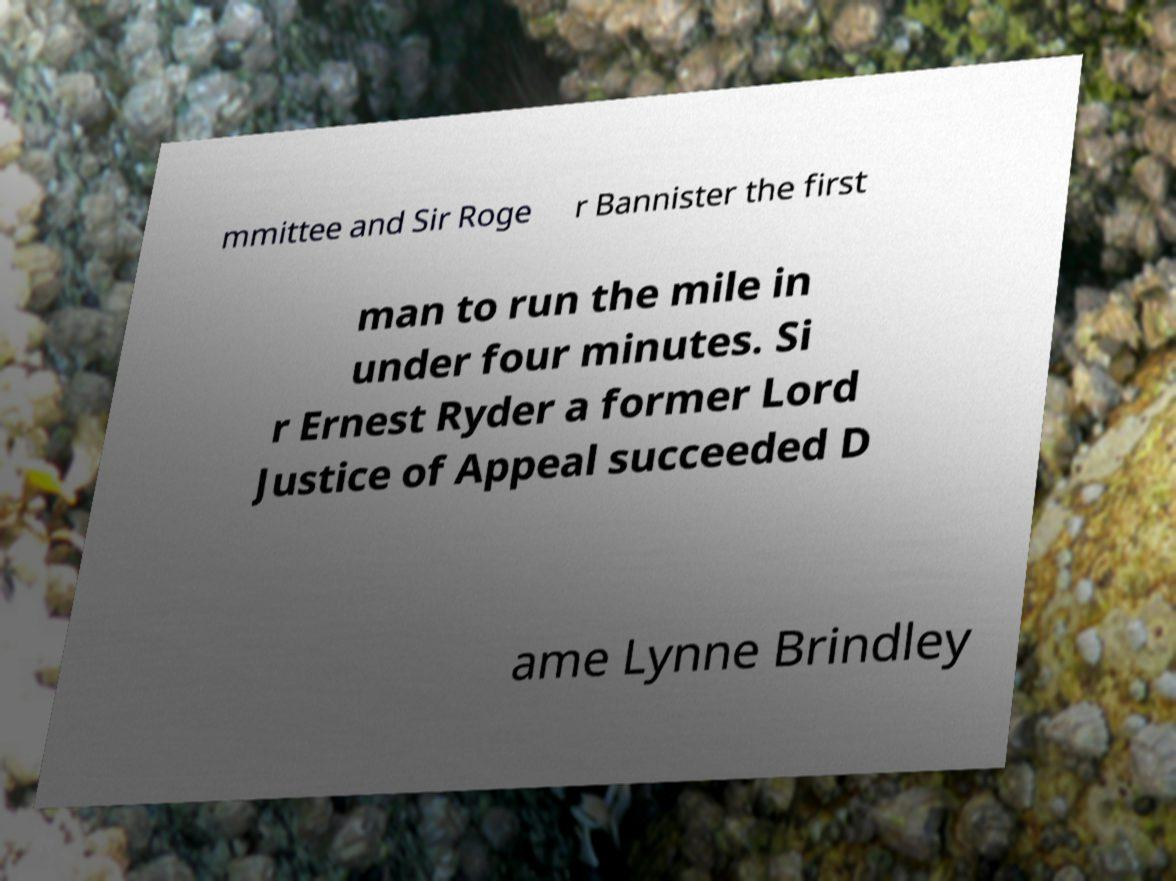Can you read and provide the text displayed in the image?This photo seems to have some interesting text. Can you extract and type it out for me? mmittee and Sir Roge r Bannister the first man to run the mile in under four minutes. Si r Ernest Ryder a former Lord Justice of Appeal succeeded D ame Lynne Brindley 